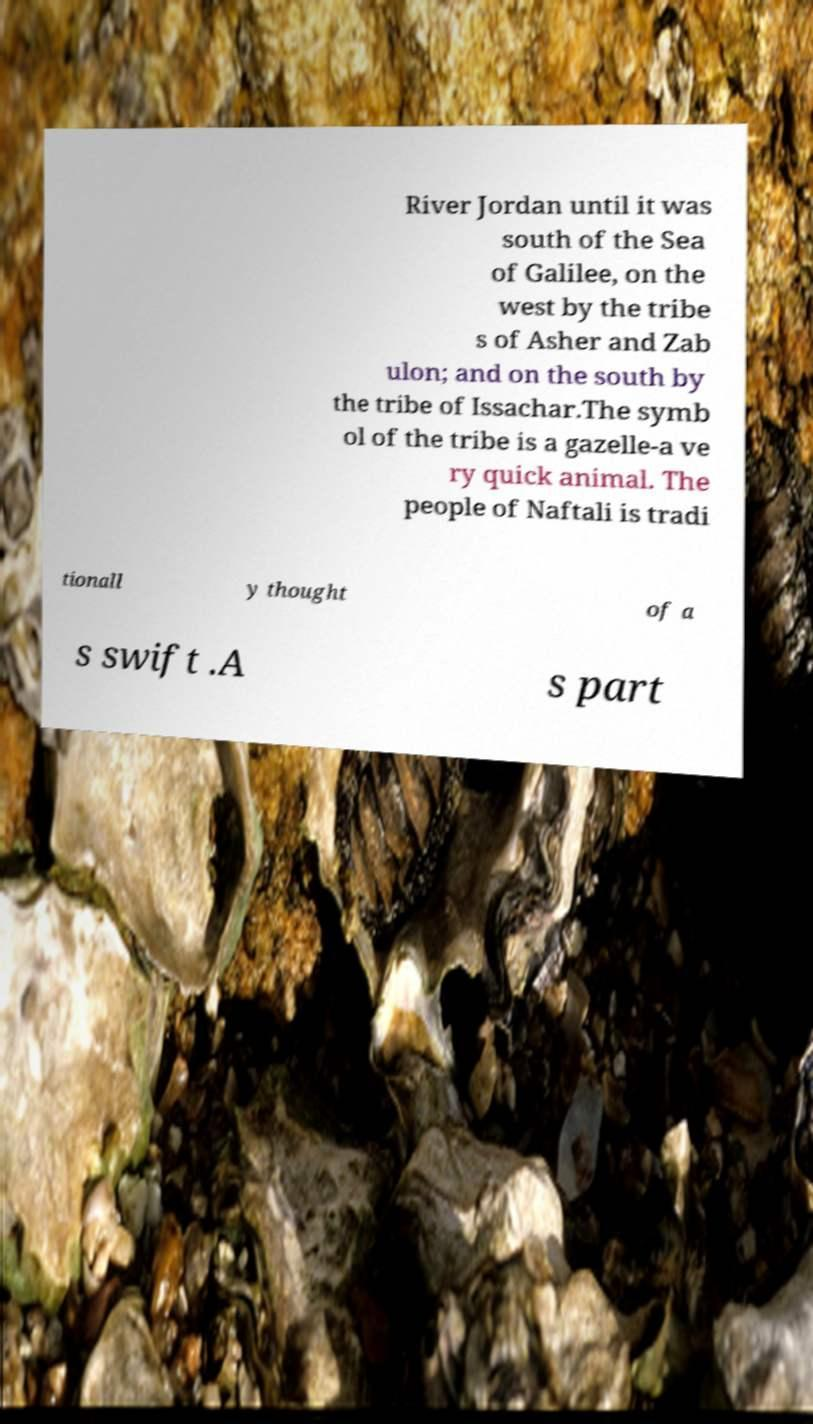Could you assist in decoding the text presented in this image and type it out clearly? River Jordan until it was south of the Sea of Galilee, on the west by the tribe s of Asher and Zab ulon; and on the south by the tribe of Issachar.The symb ol of the tribe is a gazelle-a ve ry quick animal. The people of Naftali is tradi tionall y thought of a s swift .A s part 